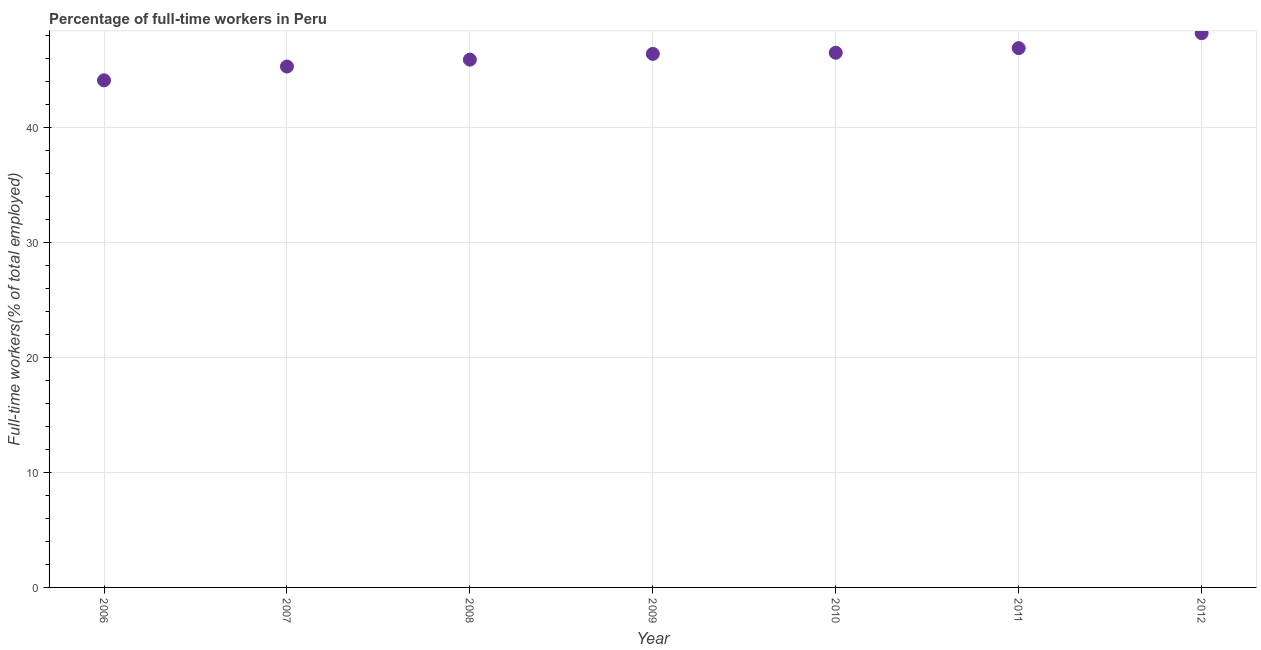What is the percentage of full-time workers in 2007?
Keep it short and to the point. 45.3. Across all years, what is the maximum percentage of full-time workers?
Offer a terse response. 48.2. Across all years, what is the minimum percentage of full-time workers?
Provide a succinct answer. 44.1. What is the sum of the percentage of full-time workers?
Your answer should be very brief. 323.3. What is the difference between the percentage of full-time workers in 2009 and 2011?
Provide a short and direct response. -0.5. What is the average percentage of full-time workers per year?
Ensure brevity in your answer.  46.19. What is the median percentage of full-time workers?
Keep it short and to the point. 46.4. In how many years, is the percentage of full-time workers greater than 38 %?
Offer a terse response. 7. Do a majority of the years between 2007 and 2010 (inclusive) have percentage of full-time workers greater than 14 %?
Keep it short and to the point. Yes. What is the ratio of the percentage of full-time workers in 2007 to that in 2012?
Provide a short and direct response. 0.94. Is the percentage of full-time workers in 2010 less than that in 2011?
Your answer should be very brief. Yes. What is the difference between the highest and the second highest percentage of full-time workers?
Keep it short and to the point. 1.3. Is the sum of the percentage of full-time workers in 2006 and 2009 greater than the maximum percentage of full-time workers across all years?
Give a very brief answer. Yes. What is the difference between the highest and the lowest percentage of full-time workers?
Your answer should be very brief. 4.1. In how many years, is the percentage of full-time workers greater than the average percentage of full-time workers taken over all years?
Your response must be concise. 4. How many dotlines are there?
Ensure brevity in your answer.  1. How many years are there in the graph?
Your answer should be very brief. 7. What is the difference between two consecutive major ticks on the Y-axis?
Offer a terse response. 10. Are the values on the major ticks of Y-axis written in scientific E-notation?
Your answer should be compact. No. Does the graph contain any zero values?
Your response must be concise. No. Does the graph contain grids?
Provide a succinct answer. Yes. What is the title of the graph?
Give a very brief answer. Percentage of full-time workers in Peru. What is the label or title of the Y-axis?
Provide a succinct answer. Full-time workers(% of total employed). What is the Full-time workers(% of total employed) in 2006?
Keep it short and to the point. 44.1. What is the Full-time workers(% of total employed) in 2007?
Provide a short and direct response. 45.3. What is the Full-time workers(% of total employed) in 2008?
Offer a terse response. 45.9. What is the Full-time workers(% of total employed) in 2009?
Your response must be concise. 46.4. What is the Full-time workers(% of total employed) in 2010?
Your answer should be compact. 46.5. What is the Full-time workers(% of total employed) in 2011?
Offer a terse response. 46.9. What is the Full-time workers(% of total employed) in 2012?
Ensure brevity in your answer.  48.2. What is the difference between the Full-time workers(% of total employed) in 2006 and 2007?
Ensure brevity in your answer.  -1.2. What is the difference between the Full-time workers(% of total employed) in 2006 and 2008?
Your response must be concise. -1.8. What is the difference between the Full-time workers(% of total employed) in 2006 and 2009?
Provide a short and direct response. -2.3. What is the difference between the Full-time workers(% of total employed) in 2007 and 2010?
Your answer should be compact. -1.2. What is the difference between the Full-time workers(% of total employed) in 2009 and 2010?
Offer a terse response. -0.1. What is the difference between the Full-time workers(% of total employed) in 2009 and 2011?
Offer a terse response. -0.5. What is the difference between the Full-time workers(% of total employed) in 2010 and 2012?
Your response must be concise. -1.7. What is the difference between the Full-time workers(% of total employed) in 2011 and 2012?
Offer a terse response. -1.3. What is the ratio of the Full-time workers(% of total employed) in 2006 to that in 2008?
Provide a short and direct response. 0.96. What is the ratio of the Full-time workers(% of total employed) in 2006 to that in 2009?
Offer a terse response. 0.95. What is the ratio of the Full-time workers(% of total employed) in 2006 to that in 2010?
Provide a succinct answer. 0.95. What is the ratio of the Full-time workers(% of total employed) in 2006 to that in 2012?
Keep it short and to the point. 0.92. What is the ratio of the Full-time workers(% of total employed) in 2007 to that in 2008?
Offer a very short reply. 0.99. What is the ratio of the Full-time workers(% of total employed) in 2007 to that in 2009?
Keep it short and to the point. 0.98. What is the ratio of the Full-time workers(% of total employed) in 2007 to that in 2010?
Your answer should be very brief. 0.97. What is the ratio of the Full-time workers(% of total employed) in 2007 to that in 2012?
Provide a short and direct response. 0.94. What is the ratio of the Full-time workers(% of total employed) in 2008 to that in 2010?
Ensure brevity in your answer.  0.99. What is the ratio of the Full-time workers(% of total employed) in 2009 to that in 2012?
Your answer should be very brief. 0.96. 